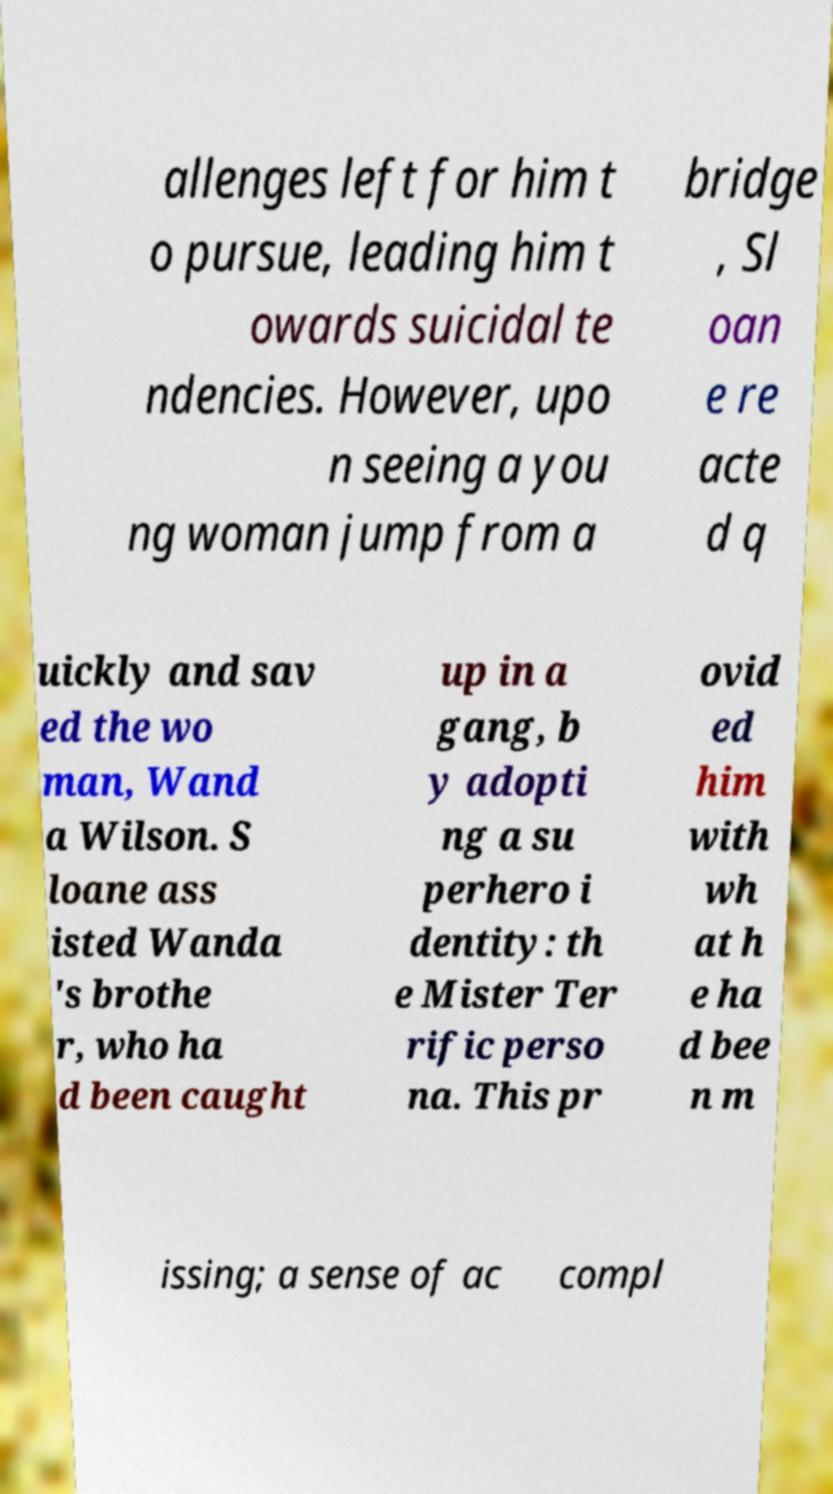Could you assist in decoding the text presented in this image and type it out clearly? allenges left for him t o pursue, leading him t owards suicidal te ndencies. However, upo n seeing a you ng woman jump from a bridge , Sl oan e re acte d q uickly and sav ed the wo man, Wand a Wilson. S loane ass isted Wanda 's brothe r, who ha d been caught up in a gang, b y adopti ng a su perhero i dentity: th e Mister Ter rific perso na. This pr ovid ed him with wh at h e ha d bee n m issing; a sense of ac compl 